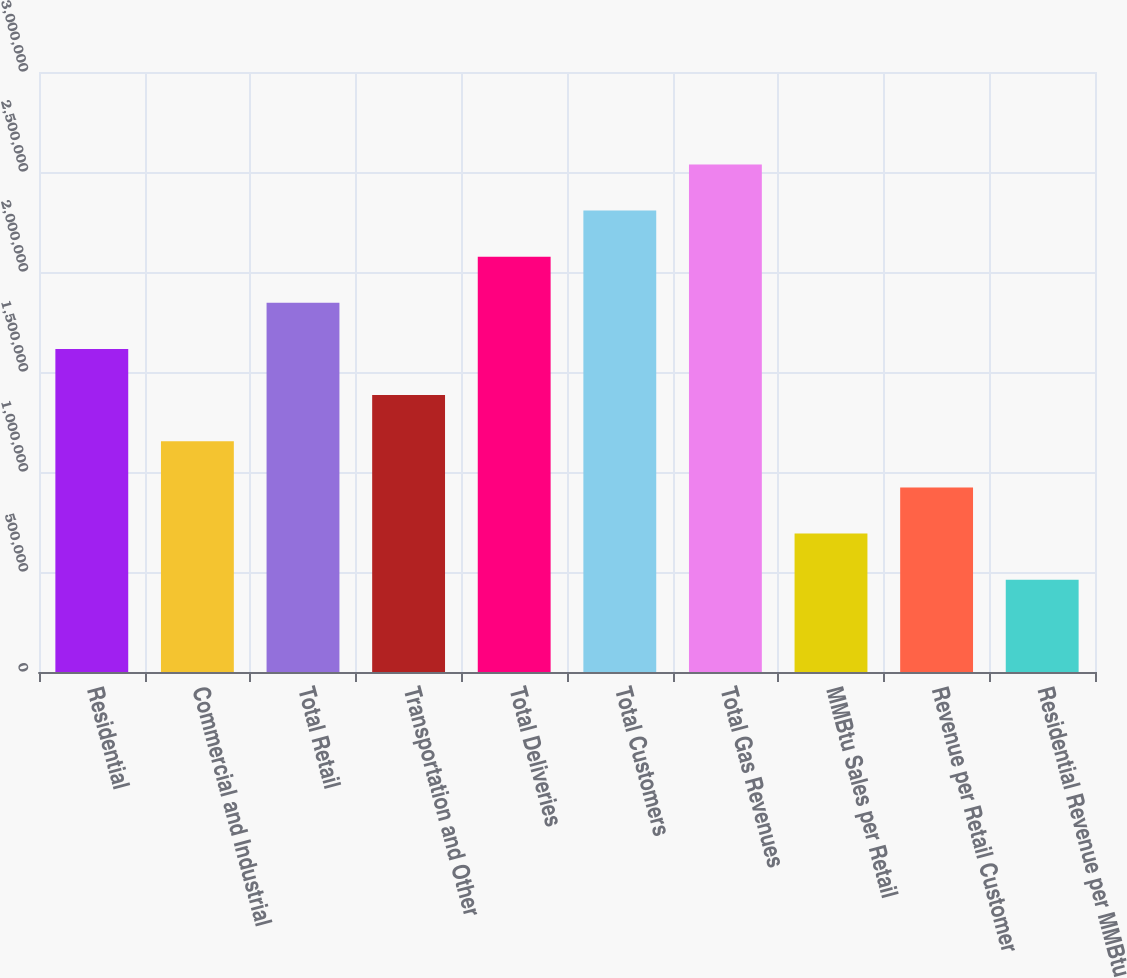Convert chart. <chart><loc_0><loc_0><loc_500><loc_500><bar_chart><fcel>Residential<fcel>Commercial and Industrial<fcel>Total Retail<fcel>Transportation and Other<fcel>Total Deliveries<fcel>Total Customers<fcel>Total Gas Revenues<fcel>MMBtu Sales per Retail<fcel>Revenue per Retail Customer<fcel>Residential Revenue per MMBtu<nl><fcel>1.61517e+06<fcel>1.15369e+06<fcel>1.84591e+06<fcel>1.38443e+06<fcel>2.07665e+06<fcel>2.30738e+06<fcel>2.53812e+06<fcel>692216<fcel>922954<fcel>461477<nl></chart> 